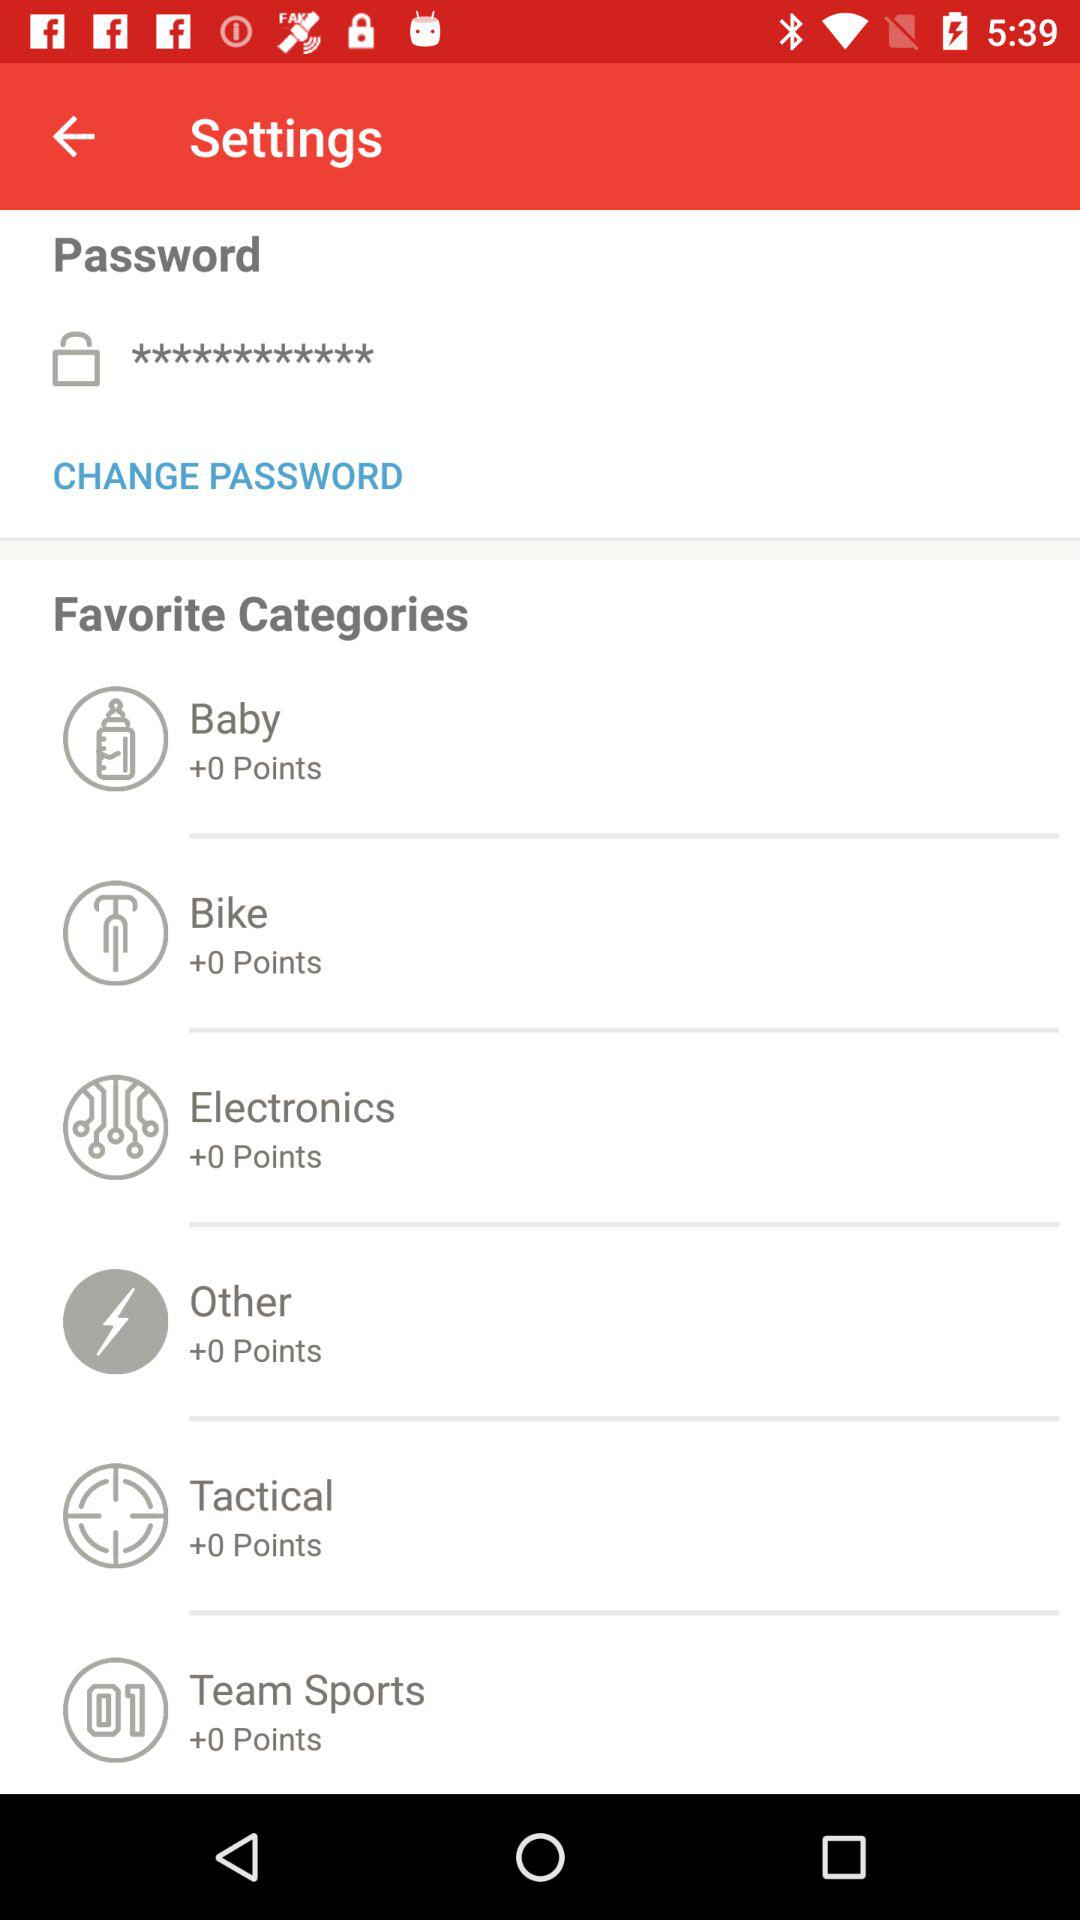How many points do I have in the Tactical category?
Answer the question using a single word or phrase. 0 